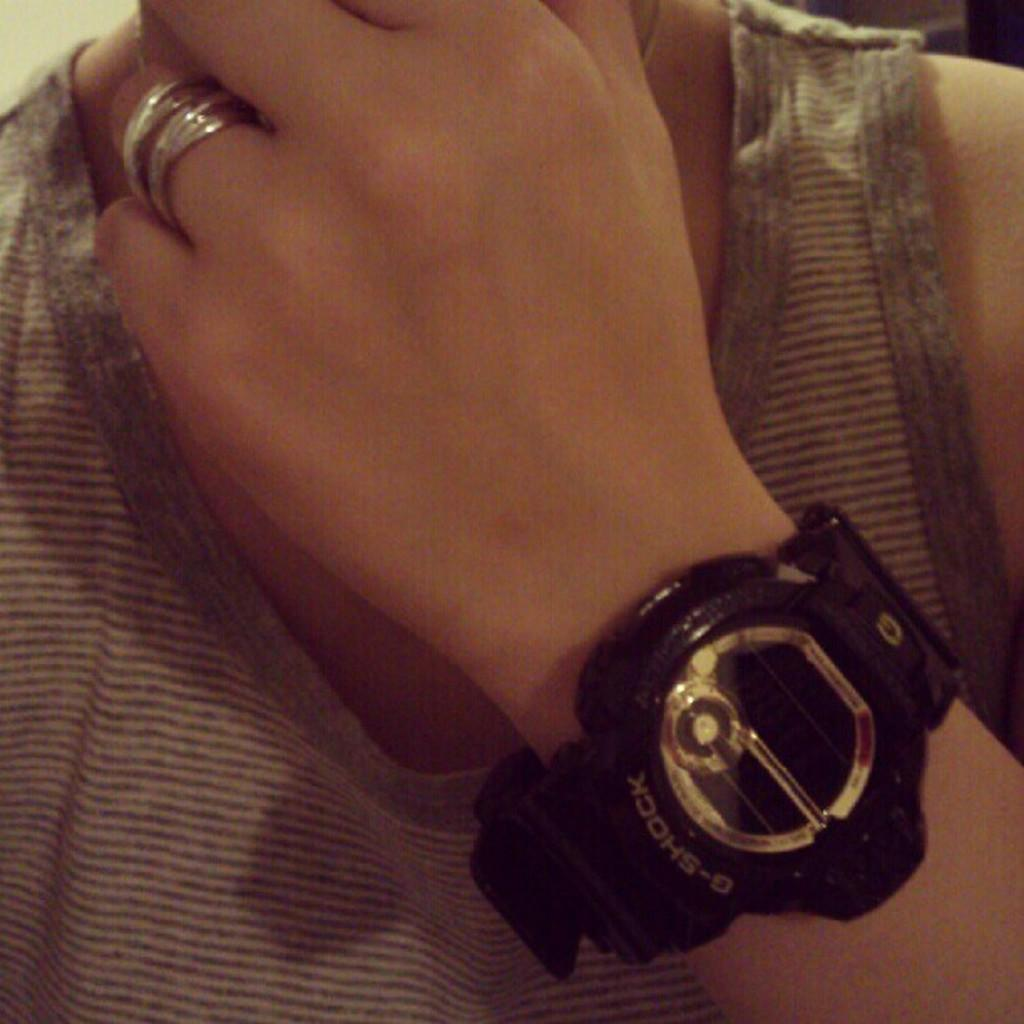Who or what is the main subject of the image? There is a person in the image. What accessories can be seen on the person? The person is wearing rings and a wristwatch. What type of error can be seen in the image? There is no error present in the image; it features a person wearing rings and a wristwatch. What song is the person singing in the image? There is no indication in the image that the person is singing a song, so it cannot be determined from the picture. 